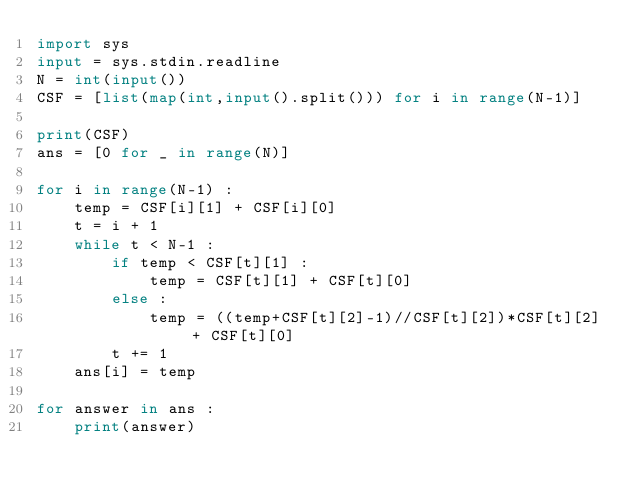<code> <loc_0><loc_0><loc_500><loc_500><_Python_>import sys
input = sys.stdin.readline
N = int(input())
CSF = [list(map(int,input().split())) for i in range(N-1)]

print(CSF)
ans = [0 for _ in range(N)]

for i in range(N-1) :
    temp = CSF[i][1] + CSF[i][0]
    t = i + 1
    while t < N-1 :
        if temp < CSF[t][1] :
            temp = CSF[t][1] + CSF[t][0]
        else :
            temp = ((temp+CSF[t][2]-1)//CSF[t][2])*CSF[t][2] + CSF[t][0]
        t += 1
    ans[i] = temp

for answer in ans :
    print(answer)
</code> 